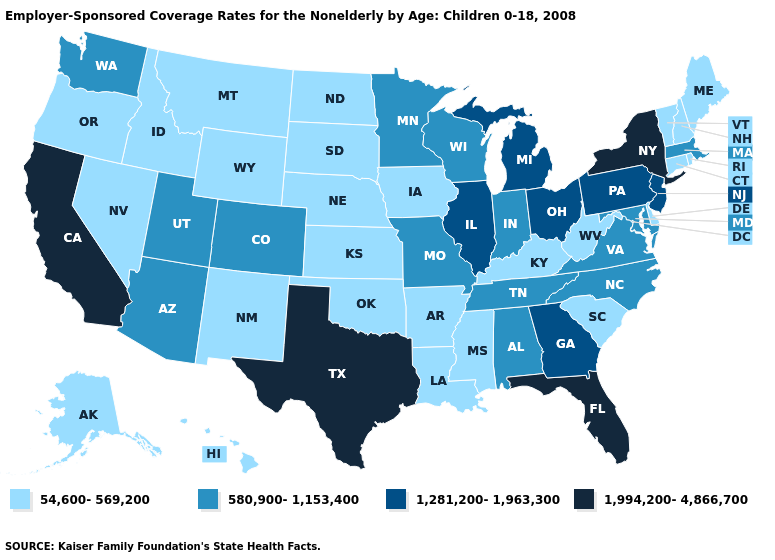What is the value of Oklahoma?
Keep it brief. 54,600-569,200. Does the first symbol in the legend represent the smallest category?
Concise answer only. Yes. Which states have the lowest value in the South?
Quick response, please. Arkansas, Delaware, Kentucky, Louisiana, Mississippi, Oklahoma, South Carolina, West Virginia. Which states have the highest value in the USA?
Keep it brief. California, Florida, New York, Texas. What is the lowest value in states that border Virginia?
Give a very brief answer. 54,600-569,200. Name the states that have a value in the range 54,600-569,200?
Give a very brief answer. Alaska, Arkansas, Connecticut, Delaware, Hawaii, Idaho, Iowa, Kansas, Kentucky, Louisiana, Maine, Mississippi, Montana, Nebraska, Nevada, New Hampshire, New Mexico, North Dakota, Oklahoma, Oregon, Rhode Island, South Carolina, South Dakota, Vermont, West Virginia, Wyoming. What is the value of New Jersey?
Keep it brief. 1,281,200-1,963,300. What is the lowest value in the West?
Keep it brief. 54,600-569,200. Which states have the highest value in the USA?
Short answer required. California, Florida, New York, Texas. Is the legend a continuous bar?
Be succinct. No. Name the states that have a value in the range 1,281,200-1,963,300?
Be succinct. Georgia, Illinois, Michigan, New Jersey, Ohio, Pennsylvania. What is the value of Missouri?
Give a very brief answer. 580,900-1,153,400. Name the states that have a value in the range 1,994,200-4,866,700?
Give a very brief answer. California, Florida, New York, Texas. Does the first symbol in the legend represent the smallest category?
Answer briefly. Yes. Which states hav the highest value in the South?
Answer briefly. Florida, Texas. 